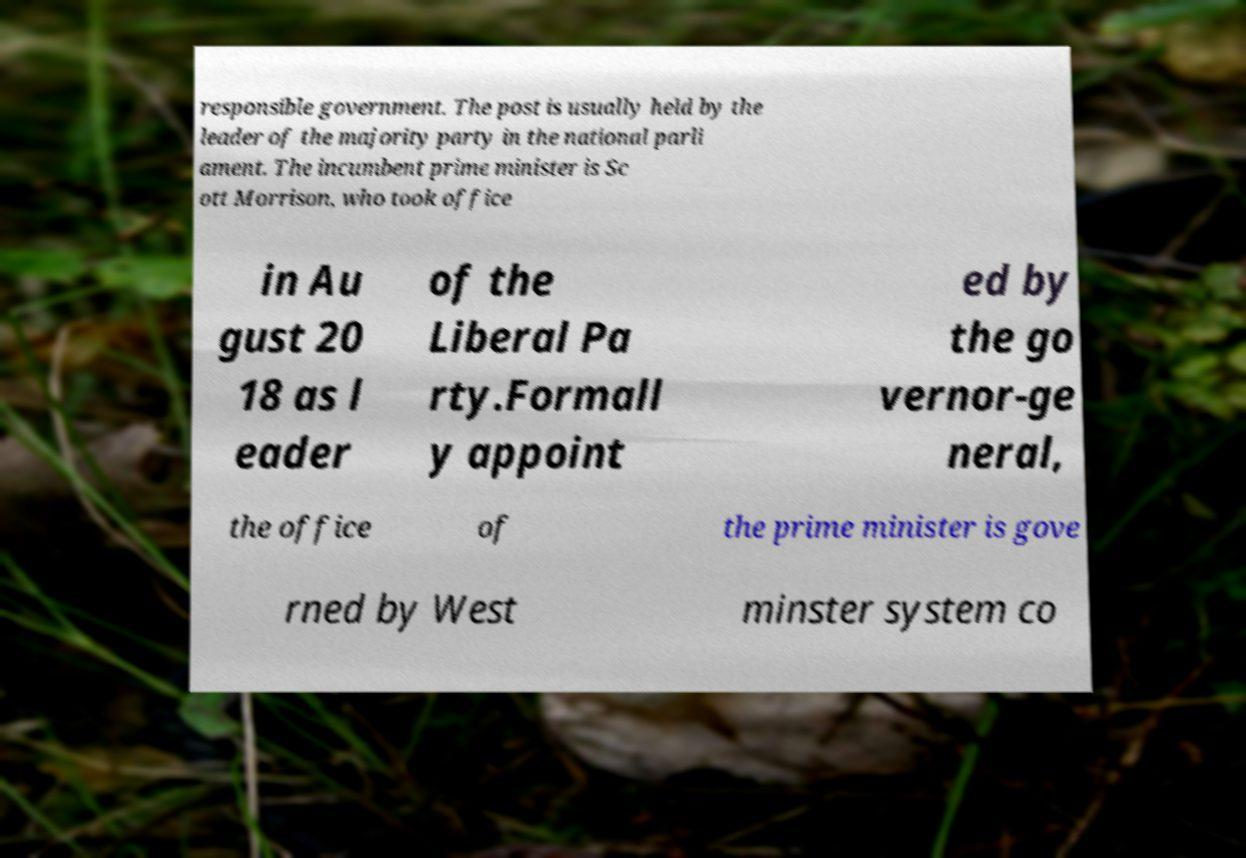Please identify and transcribe the text found in this image. responsible government. The post is usually held by the leader of the majority party in the national parli ament. The incumbent prime minister is Sc ott Morrison, who took office in Au gust 20 18 as l eader of the Liberal Pa rty.Formall y appoint ed by the go vernor-ge neral, the office of the prime minister is gove rned by West minster system co 